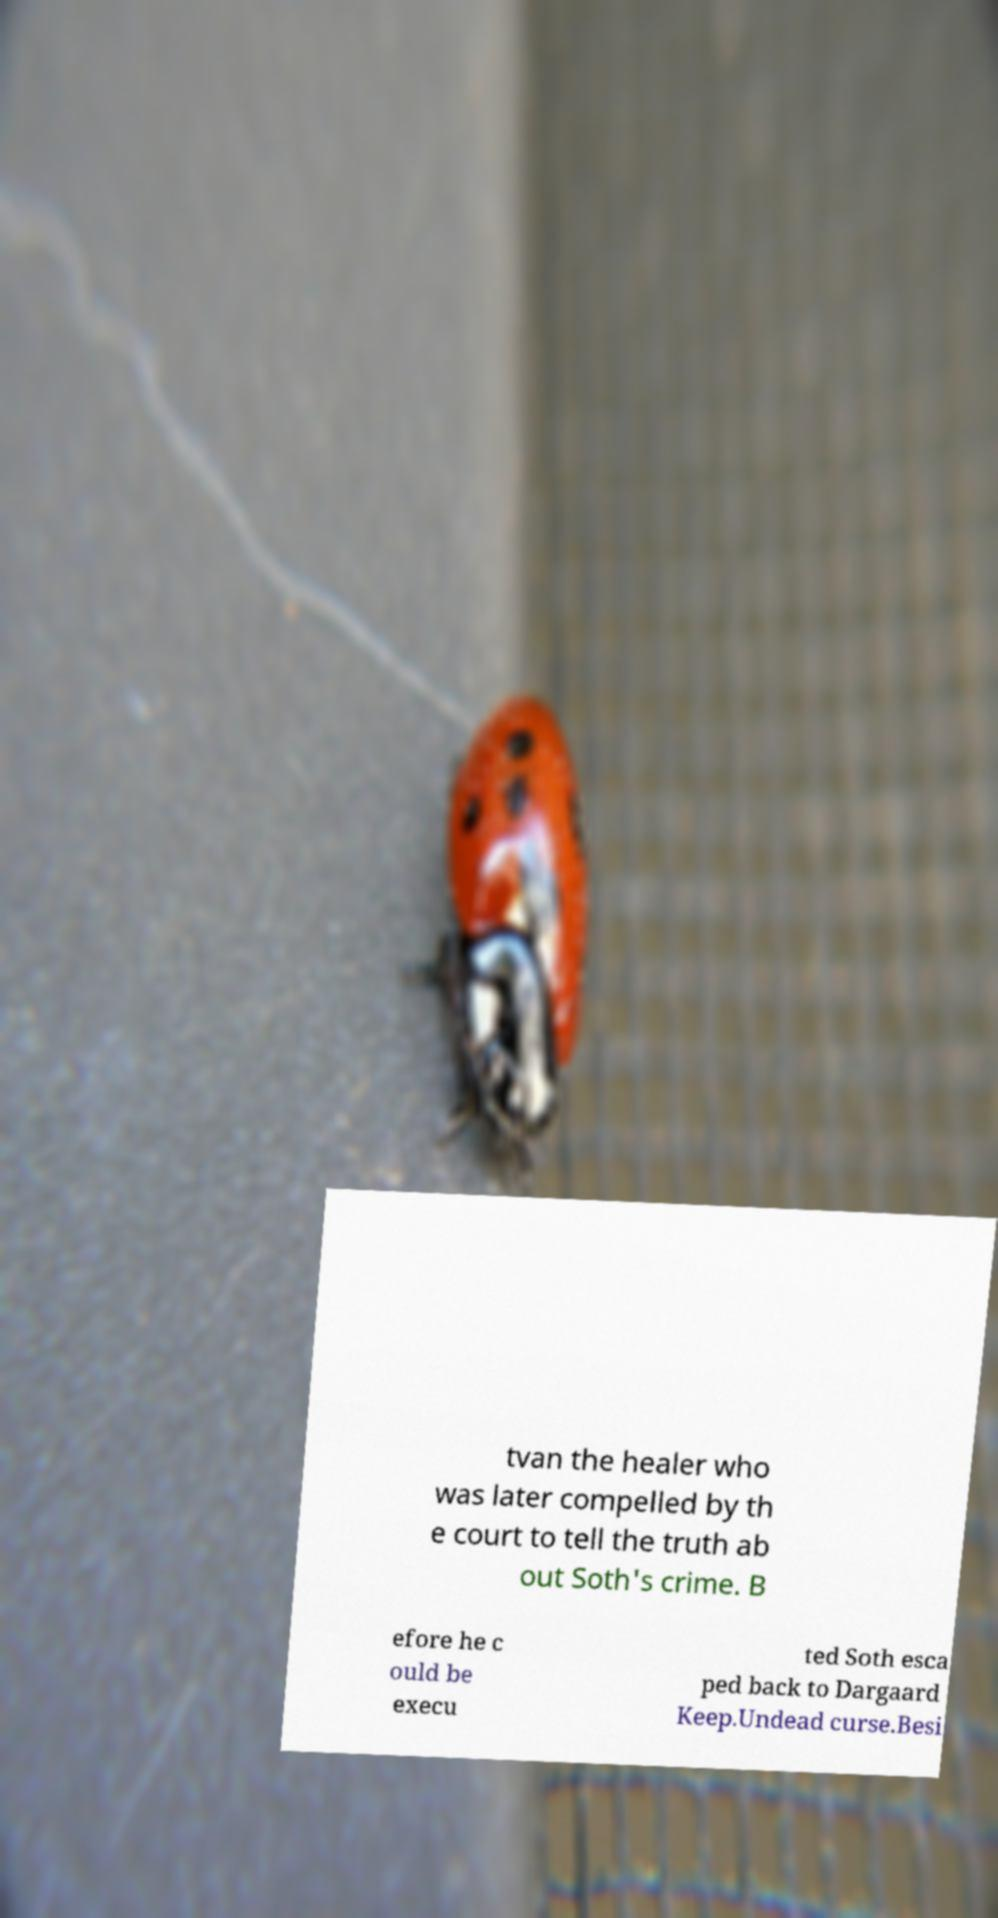There's text embedded in this image that I need extracted. Can you transcribe it verbatim? tvan the healer who was later compelled by th e court to tell the truth ab out Soth's crime. B efore he c ould be execu ted Soth esca ped back to Dargaard Keep.Undead curse.Besi 